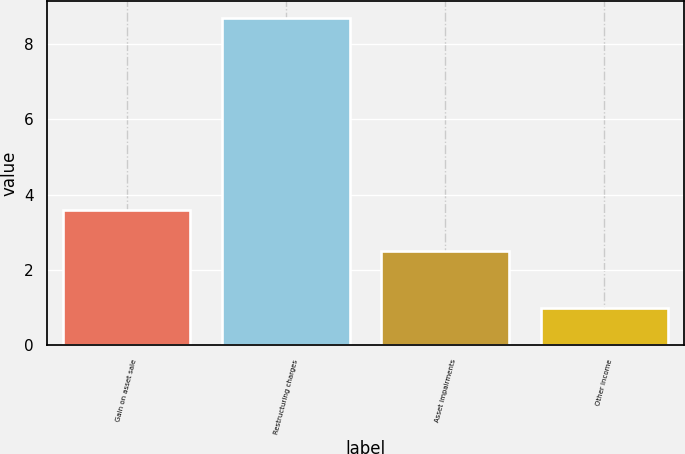Convert chart. <chart><loc_0><loc_0><loc_500><loc_500><bar_chart><fcel>Gain on asset sale<fcel>Restructuring charges<fcel>Asset impairments<fcel>Other income<nl><fcel>3.6<fcel>8.7<fcel>2.5<fcel>1<nl></chart> 